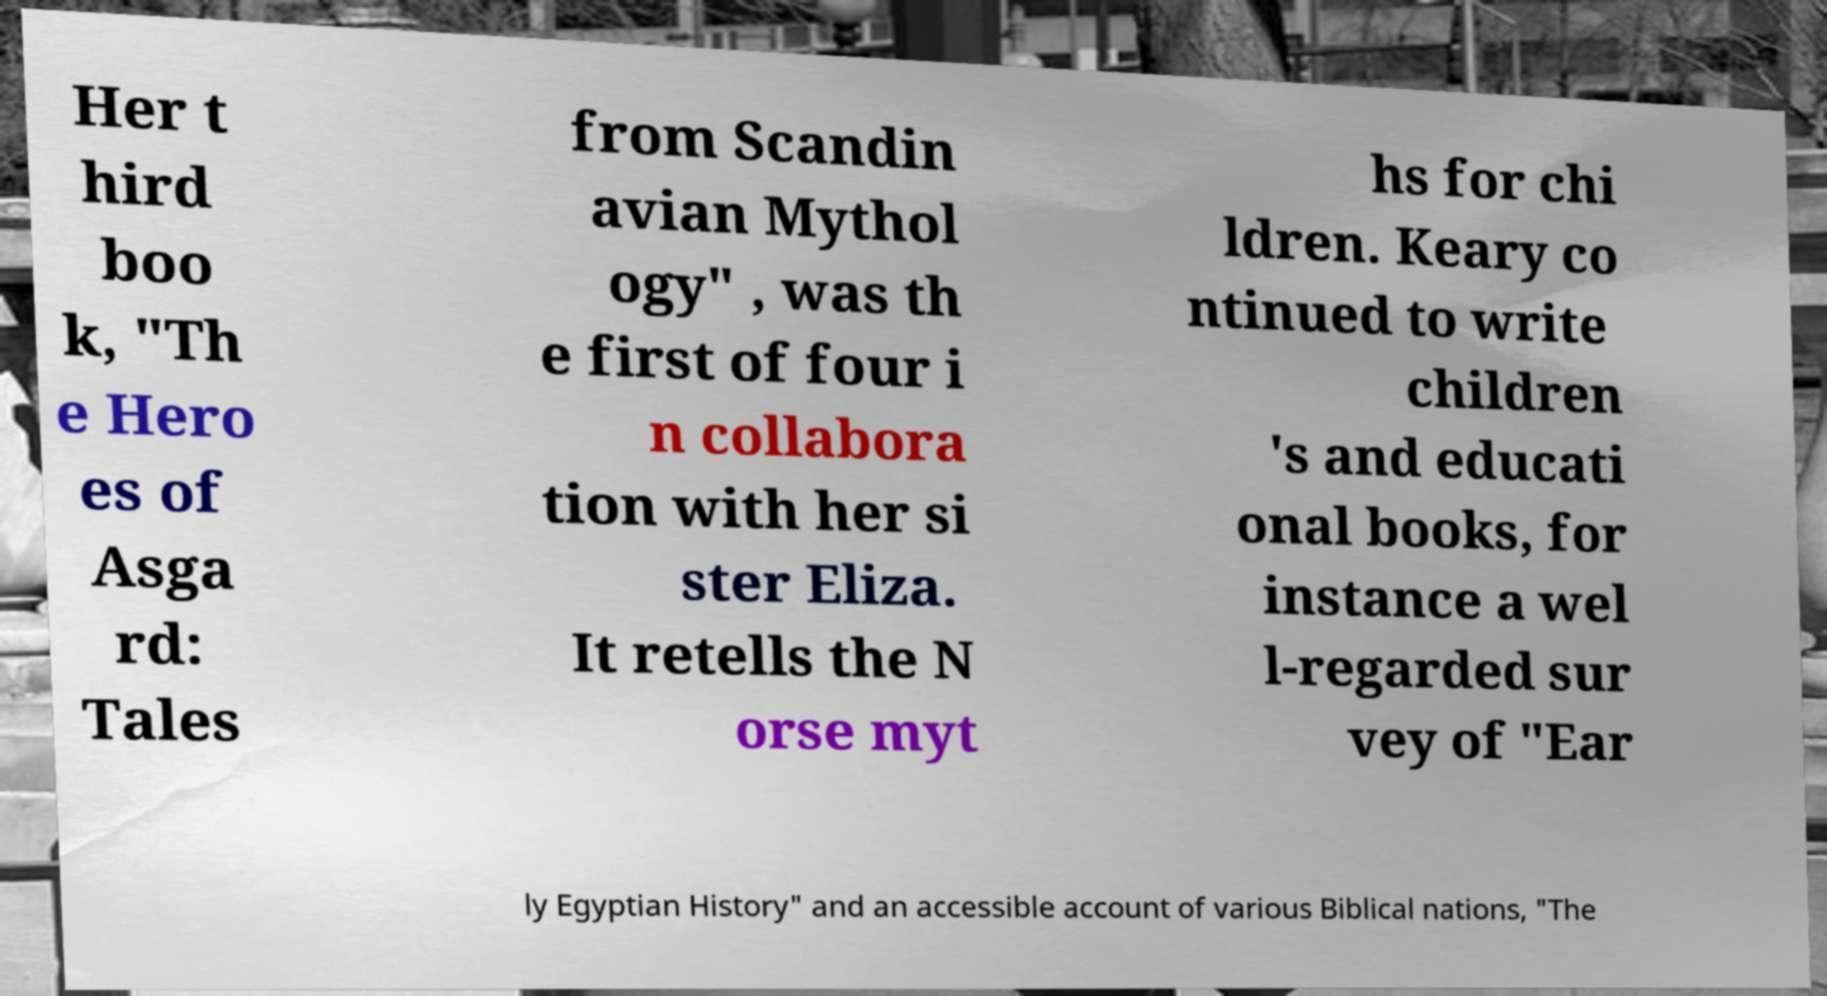Please identify and transcribe the text found in this image. Her t hird boo k, "Th e Hero es of Asga rd: Tales from Scandin avian Mythol ogy" , was th e first of four i n collabora tion with her si ster Eliza. It retells the N orse myt hs for chi ldren. Keary co ntinued to write children 's and educati onal books, for instance a wel l-regarded sur vey of "Ear ly Egyptian History" and an accessible account of various Biblical nations, "The 